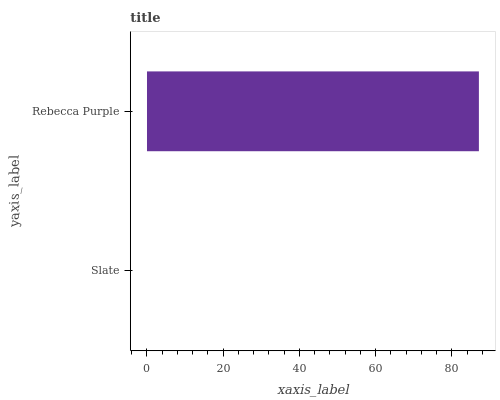Is Slate the minimum?
Answer yes or no. Yes. Is Rebecca Purple the maximum?
Answer yes or no. Yes. Is Rebecca Purple the minimum?
Answer yes or no. No. Is Rebecca Purple greater than Slate?
Answer yes or no. Yes. Is Slate less than Rebecca Purple?
Answer yes or no. Yes. Is Slate greater than Rebecca Purple?
Answer yes or no. No. Is Rebecca Purple less than Slate?
Answer yes or no. No. Is Rebecca Purple the high median?
Answer yes or no. Yes. Is Slate the low median?
Answer yes or no. Yes. Is Slate the high median?
Answer yes or no. No. Is Rebecca Purple the low median?
Answer yes or no. No. 